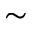<formula> <loc_0><loc_0><loc_500><loc_500>\sim</formula> 